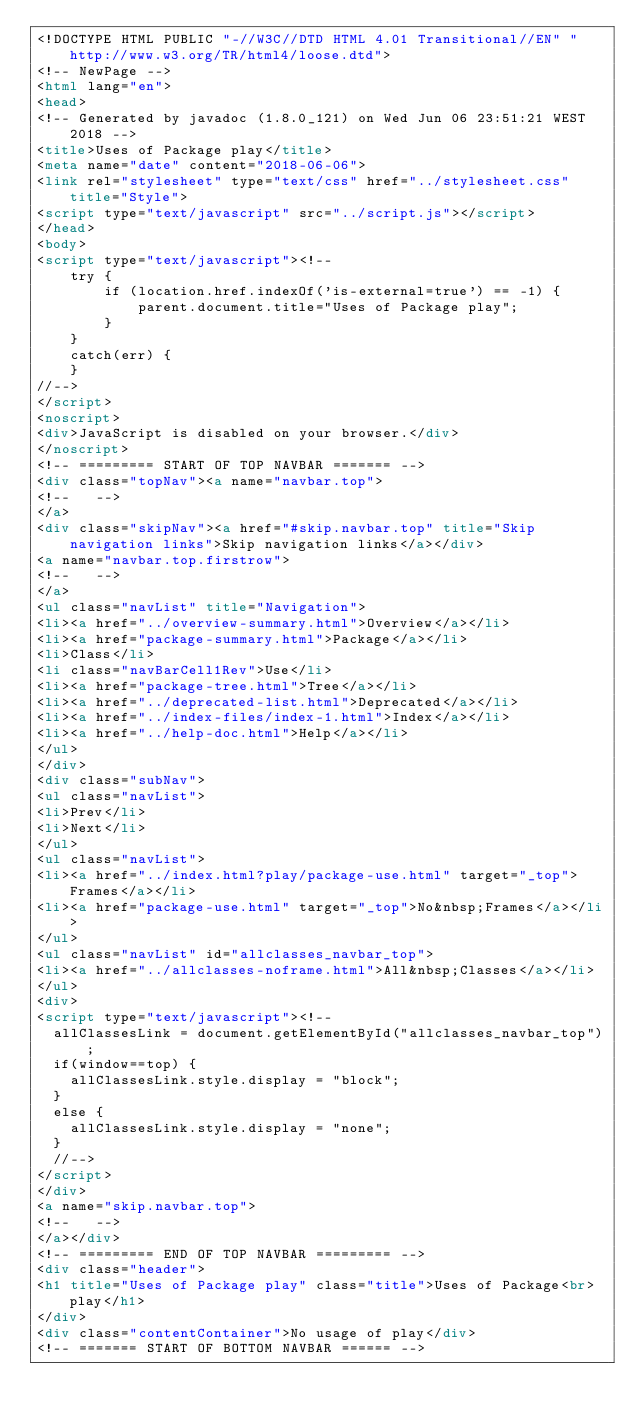Convert code to text. <code><loc_0><loc_0><loc_500><loc_500><_HTML_><!DOCTYPE HTML PUBLIC "-//W3C//DTD HTML 4.01 Transitional//EN" "http://www.w3.org/TR/html4/loose.dtd">
<!-- NewPage -->
<html lang="en">
<head>
<!-- Generated by javadoc (1.8.0_121) on Wed Jun 06 23:51:21 WEST 2018 -->
<title>Uses of Package play</title>
<meta name="date" content="2018-06-06">
<link rel="stylesheet" type="text/css" href="../stylesheet.css" title="Style">
<script type="text/javascript" src="../script.js"></script>
</head>
<body>
<script type="text/javascript"><!--
    try {
        if (location.href.indexOf('is-external=true') == -1) {
            parent.document.title="Uses of Package play";
        }
    }
    catch(err) {
    }
//-->
</script>
<noscript>
<div>JavaScript is disabled on your browser.</div>
</noscript>
<!-- ========= START OF TOP NAVBAR ======= -->
<div class="topNav"><a name="navbar.top">
<!--   -->
</a>
<div class="skipNav"><a href="#skip.navbar.top" title="Skip navigation links">Skip navigation links</a></div>
<a name="navbar.top.firstrow">
<!--   -->
</a>
<ul class="navList" title="Navigation">
<li><a href="../overview-summary.html">Overview</a></li>
<li><a href="package-summary.html">Package</a></li>
<li>Class</li>
<li class="navBarCell1Rev">Use</li>
<li><a href="package-tree.html">Tree</a></li>
<li><a href="../deprecated-list.html">Deprecated</a></li>
<li><a href="../index-files/index-1.html">Index</a></li>
<li><a href="../help-doc.html">Help</a></li>
</ul>
</div>
<div class="subNav">
<ul class="navList">
<li>Prev</li>
<li>Next</li>
</ul>
<ul class="navList">
<li><a href="../index.html?play/package-use.html" target="_top">Frames</a></li>
<li><a href="package-use.html" target="_top">No&nbsp;Frames</a></li>
</ul>
<ul class="navList" id="allclasses_navbar_top">
<li><a href="../allclasses-noframe.html">All&nbsp;Classes</a></li>
</ul>
<div>
<script type="text/javascript"><!--
  allClassesLink = document.getElementById("allclasses_navbar_top");
  if(window==top) {
    allClassesLink.style.display = "block";
  }
  else {
    allClassesLink.style.display = "none";
  }
  //-->
</script>
</div>
<a name="skip.navbar.top">
<!--   -->
</a></div>
<!-- ========= END OF TOP NAVBAR ========= -->
<div class="header">
<h1 title="Uses of Package play" class="title">Uses of Package<br>play</h1>
</div>
<div class="contentContainer">No usage of play</div>
<!-- ======= START OF BOTTOM NAVBAR ====== --></code> 